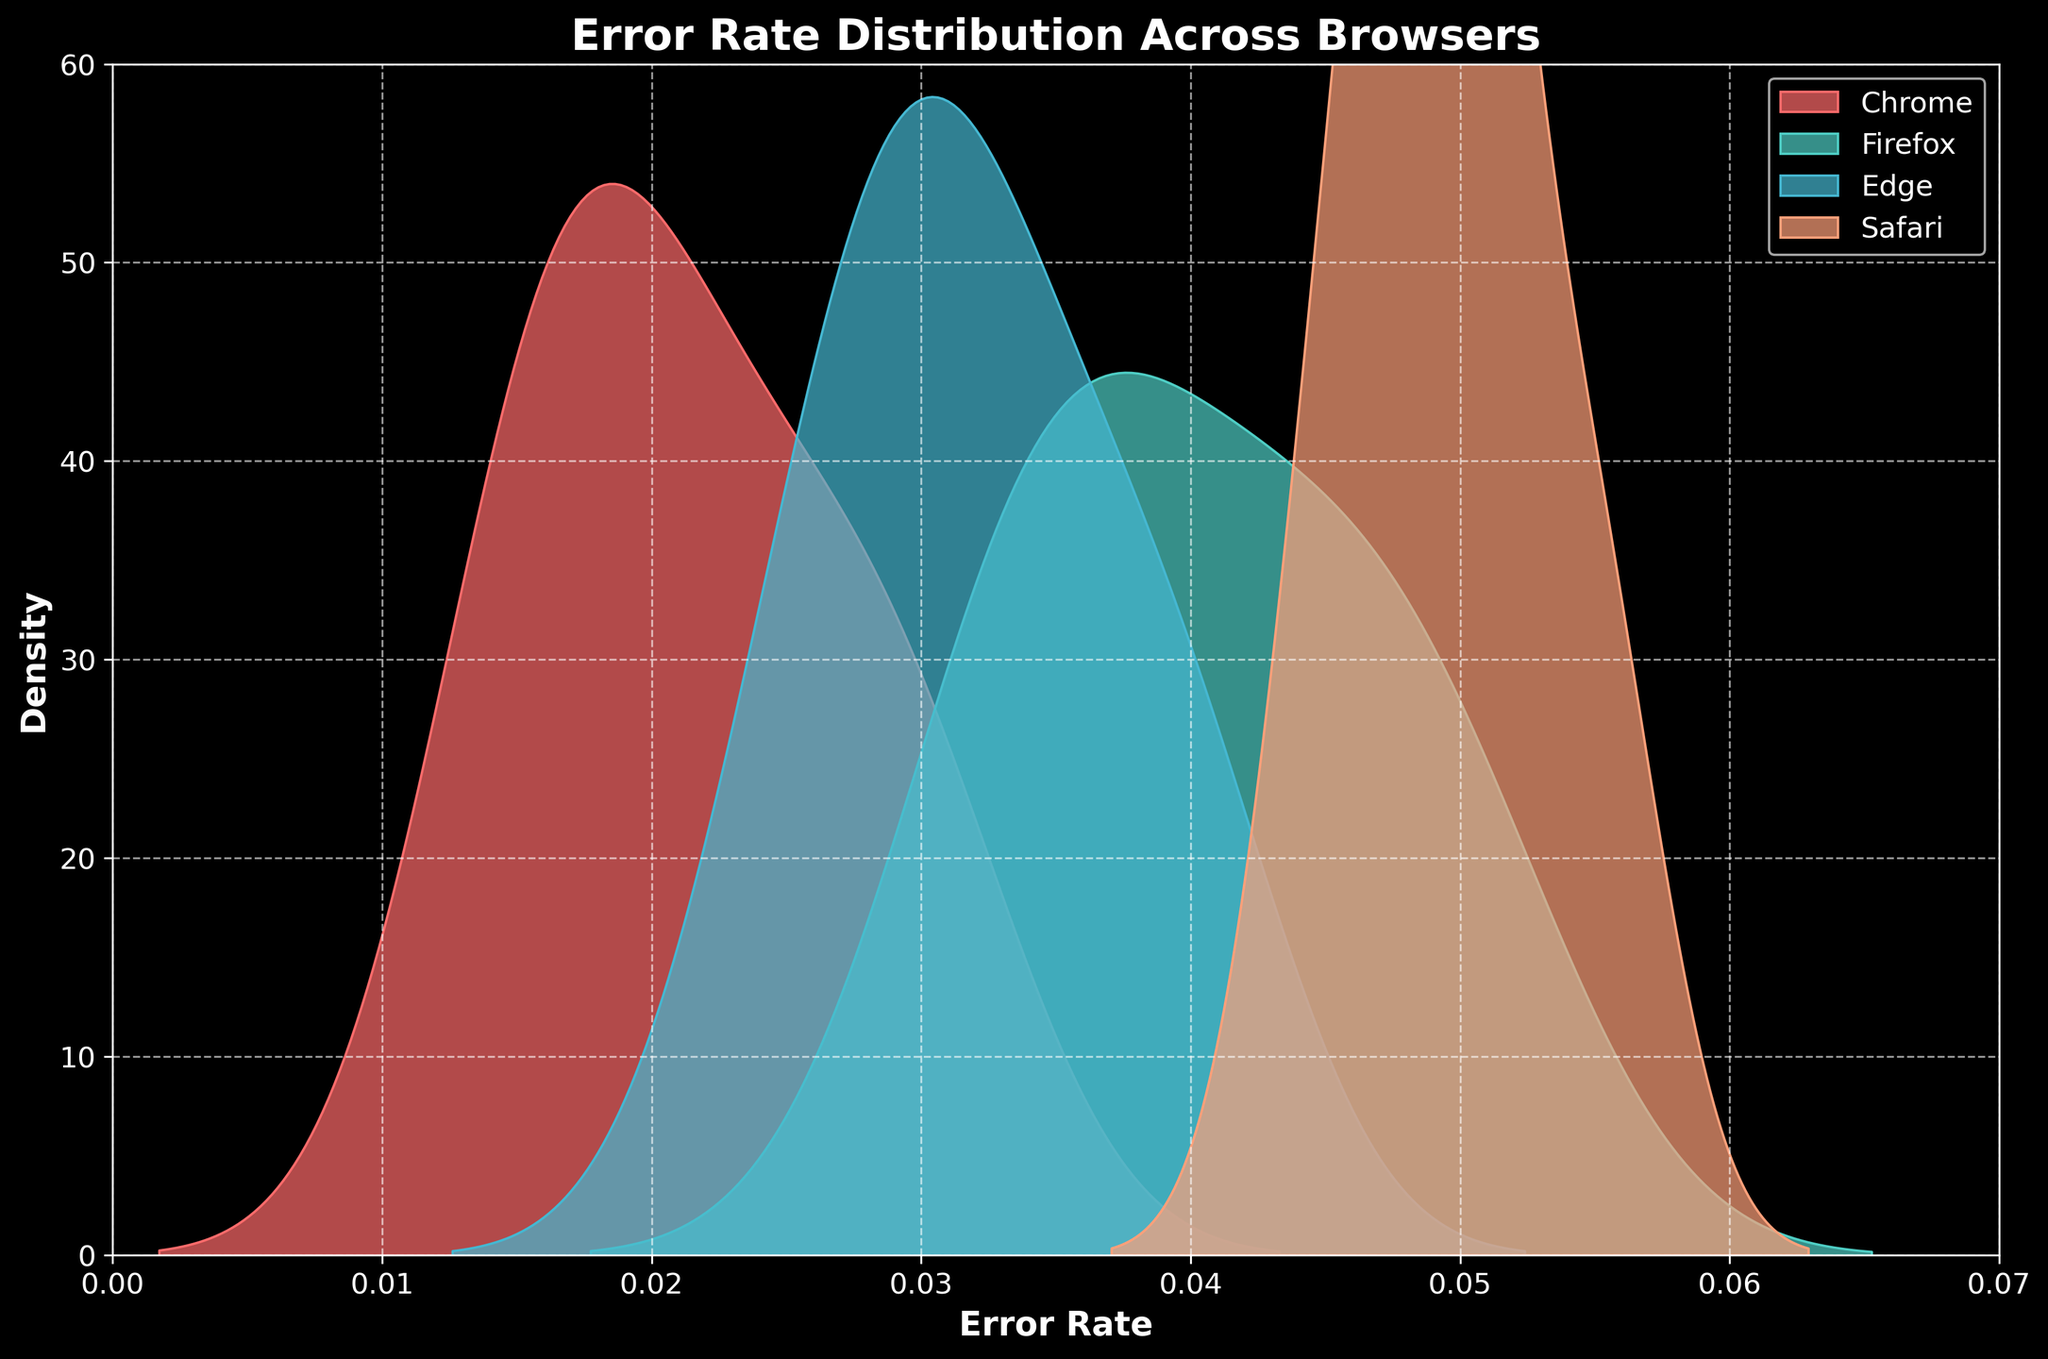What’s the title of the subplot? The title is usually displayed at the top of the plot. In this case, the title reads "Error Rate Distribution Across Browsers".
Answer: Error Rate Distribution Across Browsers What are the x and y axes representing? The x-axis represents the "Error Rate" and the y-axis represents the "Density". This can be inferred from the axis labels.
Answer: Error Rate and Density How many browsers are included in the plot? The legend and the colors show the different browsers. Chrome, Firefox, Edge, and Safari are mentioned, so there are four browsers.
Answer: Four Which color represents the Firefox browser in the density plot? In the plot, each browser is represented by a different color, and the legend indicates that Firefox is represented by a greenish color.
Answer: Greenish Is the density distribution of Chrome's error rate wider than that of Safari? By comparing the spread of the density curves, we can see that Chrome's curve is more spread out, indicating a wider distribution than the sharper peak seen in Safari's curve.
Answer: Yes Which browser has the highest peak in the density plot? By looking at the height of the peaks in the density plots, the one with the highest peak can be identified. In this case, Safari's peak is the highest.
Answer: Safari Are there any error rates where the density distributions of two different browsers overlap significantly? We need to identify regions on the x-axis (error rates) where density curves of different browsers overlap. For instance, around an error rate of 0.03, both Firefox and Edge seem to have overlapping densities.
Answer: Yes, around 0.03 Which browser has the least variability in error rates? Variability is indicated by the spread of density curves. Safari has a very sharp peak, meaning less variability, while browsers like Firefox have a broader spread, indicating more variability.
Answer: Safari What range of error rates has the densest distribution for Edge? By examining the highest density region for Edge's curve, we can see that the error rates are densest around the range of 0.03 to 0.035.
Answer: 0.03 to 0.035 How does the error rate distribution of Edge compare to Chrome? By comparing the density plots of Edge and Chrome, we find that Edge's distribution is slightly narrower and shifted to the right compared to Chrome's broader and lower distribution.
Answer: Edge is narrower and shifted to the right 